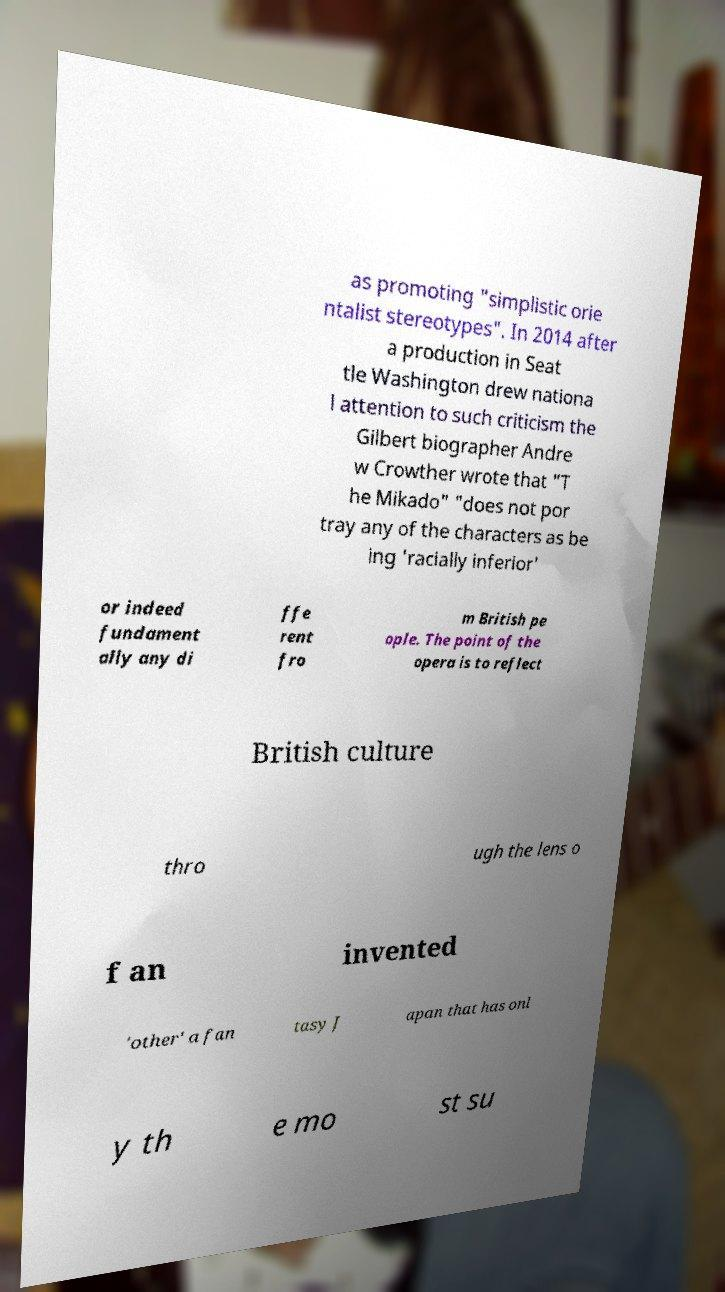Could you assist in decoding the text presented in this image and type it out clearly? as promoting "simplistic orie ntalist stereotypes". In 2014 after a production in Seat tle Washington drew nationa l attention to such criticism the Gilbert biographer Andre w Crowther wrote that "T he Mikado" "does not por tray any of the characters as be ing 'racially inferior' or indeed fundament ally any di ffe rent fro m British pe ople. The point of the opera is to reflect British culture thro ugh the lens o f an invented 'other' a fan tasy J apan that has onl y th e mo st su 